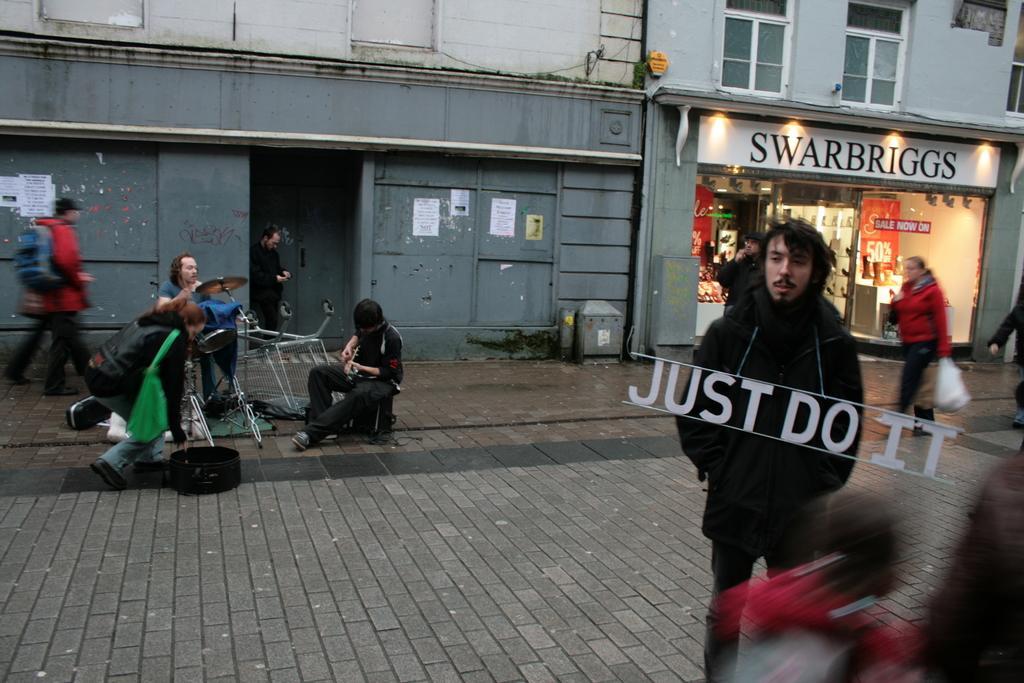How would you summarize this image in a sentence or two? Here we can see people. These people are playing musical instruments. Background there is a building and store. These are windows, hoarding and lights. In this store there are things. Posters are on the wall. 